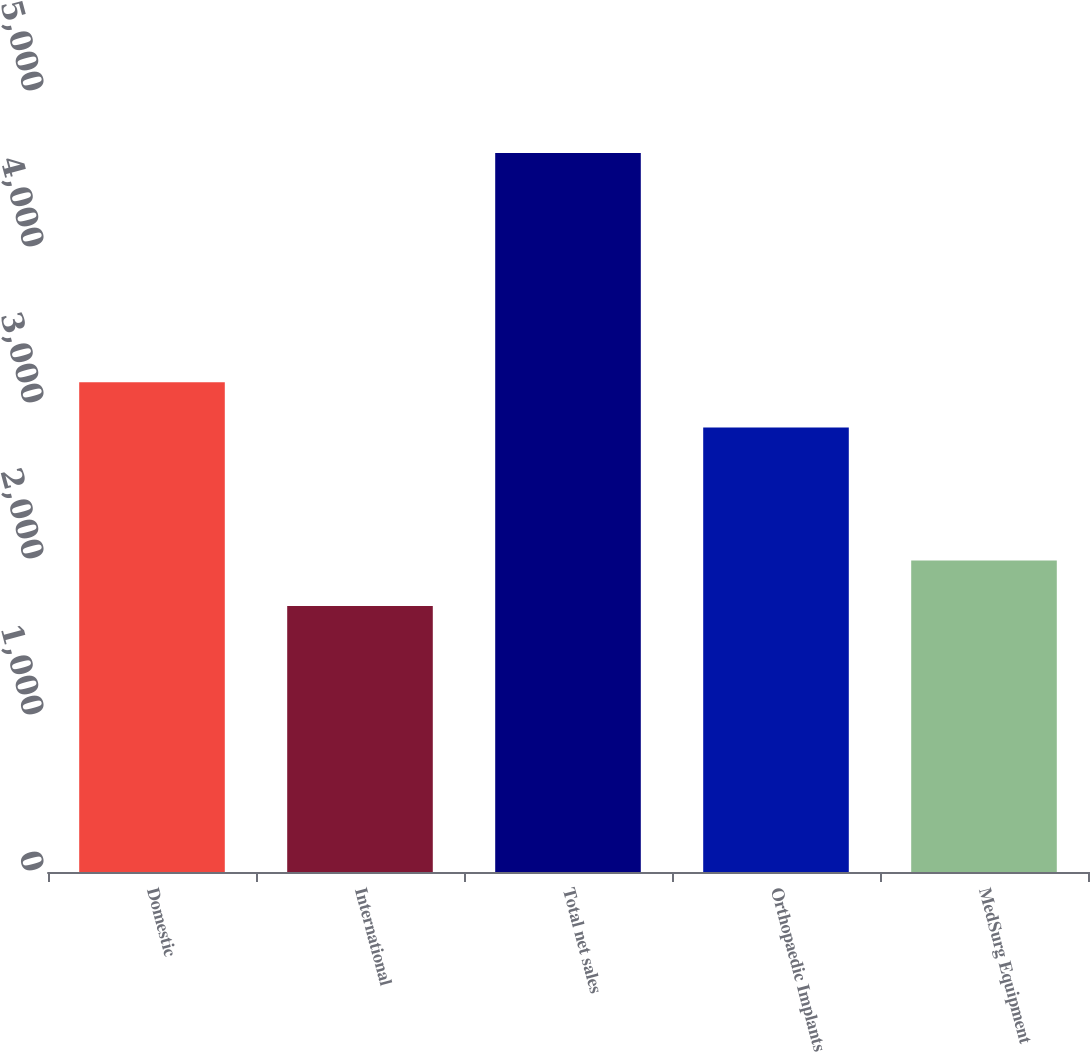Convert chart to OTSL. <chart><loc_0><loc_0><loc_500><loc_500><bar_chart><fcel>Domestic<fcel>International<fcel>Total net sales<fcel>Orthopaedic Implants<fcel>MedSurg Equipment<nl><fcel>3139.8<fcel>1705.9<fcel>4608.9<fcel>2849.5<fcel>1996.2<nl></chart> 